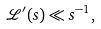<formula> <loc_0><loc_0><loc_500><loc_500>\mathcal { L } ^ { \prime } ( s ) \ll s ^ { - 1 } ,</formula> 